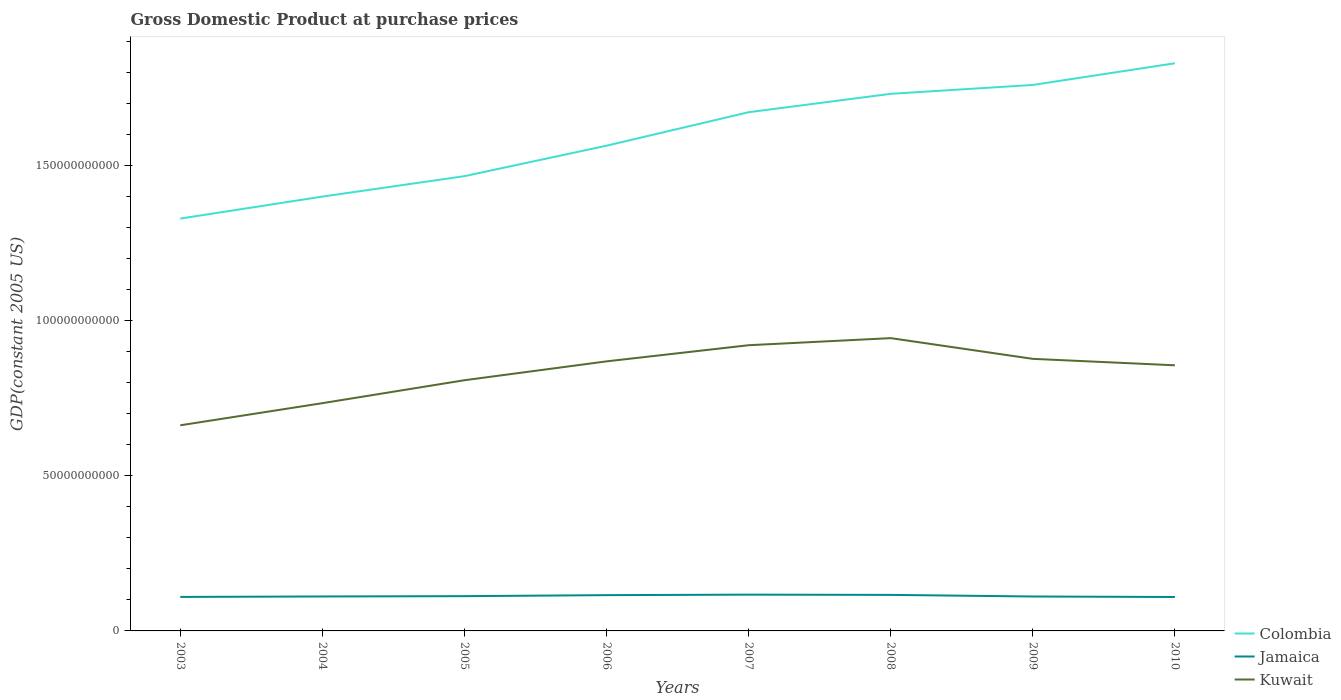How many different coloured lines are there?
Ensure brevity in your answer.  3. Across all years, what is the maximum GDP at purchase prices in Kuwait?
Offer a terse response. 6.63e+1. In which year was the GDP at purchase prices in Colombia maximum?
Make the answer very short. 2003. What is the total GDP at purchase prices in Kuwait in the graph?
Make the answer very short. -2.81e+1. What is the difference between the highest and the second highest GDP at purchase prices in Jamaica?
Make the answer very short. 7.63e+08. Is the GDP at purchase prices in Jamaica strictly greater than the GDP at purchase prices in Colombia over the years?
Give a very brief answer. Yes. How many years are there in the graph?
Give a very brief answer. 8. Does the graph contain grids?
Keep it short and to the point. No. How are the legend labels stacked?
Provide a succinct answer. Vertical. What is the title of the graph?
Your answer should be compact. Gross Domestic Product at purchase prices. What is the label or title of the X-axis?
Your answer should be compact. Years. What is the label or title of the Y-axis?
Give a very brief answer. GDP(constant 2005 US). What is the GDP(constant 2005 US) of Colombia in 2003?
Provide a short and direct response. 1.33e+11. What is the GDP(constant 2005 US) in Jamaica in 2003?
Offer a terse response. 1.10e+1. What is the GDP(constant 2005 US) of Kuwait in 2003?
Ensure brevity in your answer.  6.63e+1. What is the GDP(constant 2005 US) in Colombia in 2004?
Your response must be concise. 1.40e+11. What is the GDP(constant 2005 US) in Jamaica in 2004?
Offer a very short reply. 1.11e+1. What is the GDP(constant 2005 US) in Kuwait in 2004?
Offer a very short reply. 7.34e+1. What is the GDP(constant 2005 US) in Colombia in 2005?
Ensure brevity in your answer.  1.47e+11. What is the GDP(constant 2005 US) in Jamaica in 2005?
Keep it short and to the point. 1.12e+1. What is the GDP(constant 2005 US) of Kuwait in 2005?
Provide a short and direct response. 8.08e+1. What is the GDP(constant 2005 US) of Colombia in 2006?
Your answer should be compact. 1.56e+11. What is the GDP(constant 2005 US) in Jamaica in 2006?
Your response must be concise. 1.15e+1. What is the GDP(constant 2005 US) in Kuwait in 2006?
Ensure brevity in your answer.  8.69e+1. What is the GDP(constant 2005 US) in Colombia in 2007?
Give a very brief answer. 1.67e+11. What is the GDP(constant 2005 US) in Jamaica in 2007?
Offer a very short reply. 1.17e+1. What is the GDP(constant 2005 US) in Kuwait in 2007?
Provide a short and direct response. 9.21e+1. What is the GDP(constant 2005 US) of Colombia in 2008?
Make the answer very short. 1.73e+11. What is the GDP(constant 2005 US) of Jamaica in 2008?
Your response must be concise. 1.16e+1. What is the GDP(constant 2005 US) in Kuwait in 2008?
Your answer should be compact. 9.44e+1. What is the GDP(constant 2005 US) in Colombia in 2009?
Offer a terse response. 1.76e+11. What is the GDP(constant 2005 US) of Jamaica in 2009?
Give a very brief answer. 1.11e+1. What is the GDP(constant 2005 US) in Kuwait in 2009?
Provide a short and direct response. 8.77e+1. What is the GDP(constant 2005 US) in Colombia in 2010?
Offer a very short reply. 1.83e+11. What is the GDP(constant 2005 US) of Jamaica in 2010?
Make the answer very short. 1.09e+1. What is the GDP(constant 2005 US) of Kuwait in 2010?
Your answer should be compact. 8.56e+1. Across all years, what is the maximum GDP(constant 2005 US) of Colombia?
Give a very brief answer. 1.83e+11. Across all years, what is the maximum GDP(constant 2005 US) of Jamaica?
Ensure brevity in your answer.  1.17e+1. Across all years, what is the maximum GDP(constant 2005 US) of Kuwait?
Your answer should be compact. 9.44e+1. Across all years, what is the minimum GDP(constant 2005 US) of Colombia?
Your answer should be very brief. 1.33e+11. Across all years, what is the minimum GDP(constant 2005 US) in Jamaica?
Provide a short and direct response. 1.09e+1. Across all years, what is the minimum GDP(constant 2005 US) of Kuwait?
Make the answer very short. 6.63e+1. What is the total GDP(constant 2005 US) of Colombia in the graph?
Ensure brevity in your answer.  1.28e+12. What is the total GDP(constant 2005 US) of Jamaica in the graph?
Ensure brevity in your answer.  9.01e+1. What is the total GDP(constant 2005 US) of Kuwait in the graph?
Offer a terse response. 6.67e+11. What is the difference between the GDP(constant 2005 US) of Colombia in 2003 and that in 2004?
Provide a short and direct response. -7.09e+09. What is the difference between the GDP(constant 2005 US) of Jamaica in 2003 and that in 2004?
Provide a short and direct response. -1.45e+08. What is the difference between the GDP(constant 2005 US) of Kuwait in 2003 and that in 2004?
Ensure brevity in your answer.  -7.13e+09. What is the difference between the GDP(constant 2005 US) of Colombia in 2003 and that in 2005?
Your answer should be very brief. -1.37e+1. What is the difference between the GDP(constant 2005 US) of Jamaica in 2003 and that in 2005?
Your answer should be very brief. -2.44e+08. What is the difference between the GDP(constant 2005 US) in Kuwait in 2003 and that in 2005?
Ensure brevity in your answer.  -1.45e+1. What is the difference between the GDP(constant 2005 US) in Colombia in 2003 and that in 2006?
Make the answer very short. -2.35e+1. What is the difference between the GDP(constant 2005 US) of Jamaica in 2003 and that in 2006?
Ensure brevity in your answer.  -5.69e+08. What is the difference between the GDP(constant 2005 US) of Kuwait in 2003 and that in 2006?
Keep it short and to the point. -2.06e+1. What is the difference between the GDP(constant 2005 US) of Colombia in 2003 and that in 2007?
Offer a terse response. -3.43e+1. What is the difference between the GDP(constant 2005 US) in Jamaica in 2003 and that in 2007?
Your response must be concise. -7.34e+08. What is the difference between the GDP(constant 2005 US) in Kuwait in 2003 and that in 2007?
Offer a terse response. -2.58e+1. What is the difference between the GDP(constant 2005 US) in Colombia in 2003 and that in 2008?
Your response must be concise. -4.02e+1. What is the difference between the GDP(constant 2005 US) in Jamaica in 2003 and that in 2008?
Offer a terse response. -6.50e+08. What is the difference between the GDP(constant 2005 US) of Kuwait in 2003 and that in 2008?
Offer a terse response. -2.81e+1. What is the difference between the GDP(constant 2005 US) of Colombia in 2003 and that in 2009?
Your answer should be compact. -4.31e+1. What is the difference between the GDP(constant 2005 US) of Jamaica in 2003 and that in 2009?
Your response must be concise. -1.36e+08. What is the difference between the GDP(constant 2005 US) of Kuwait in 2003 and that in 2009?
Provide a succinct answer. -2.14e+1. What is the difference between the GDP(constant 2005 US) in Colombia in 2003 and that in 2010?
Offer a terse response. -5.01e+1. What is the difference between the GDP(constant 2005 US) in Jamaica in 2003 and that in 2010?
Offer a very short reply. 2.92e+07. What is the difference between the GDP(constant 2005 US) of Kuwait in 2003 and that in 2010?
Offer a terse response. -1.93e+1. What is the difference between the GDP(constant 2005 US) of Colombia in 2004 and that in 2005?
Your answer should be compact. -6.59e+09. What is the difference between the GDP(constant 2005 US) in Jamaica in 2004 and that in 2005?
Offer a terse response. -9.93e+07. What is the difference between the GDP(constant 2005 US) in Kuwait in 2004 and that in 2005?
Give a very brief answer. -7.40e+09. What is the difference between the GDP(constant 2005 US) in Colombia in 2004 and that in 2006?
Provide a short and direct response. -1.64e+1. What is the difference between the GDP(constant 2005 US) of Jamaica in 2004 and that in 2006?
Your answer should be compact. -4.24e+08. What is the difference between the GDP(constant 2005 US) in Kuwait in 2004 and that in 2006?
Your response must be concise. -1.35e+1. What is the difference between the GDP(constant 2005 US) in Colombia in 2004 and that in 2007?
Provide a short and direct response. -2.72e+1. What is the difference between the GDP(constant 2005 US) in Jamaica in 2004 and that in 2007?
Offer a very short reply. -5.89e+08. What is the difference between the GDP(constant 2005 US) of Kuwait in 2004 and that in 2007?
Your answer should be compact. -1.87e+1. What is the difference between the GDP(constant 2005 US) of Colombia in 2004 and that in 2008?
Keep it short and to the point. -3.31e+1. What is the difference between the GDP(constant 2005 US) in Jamaica in 2004 and that in 2008?
Provide a succinct answer. -5.05e+08. What is the difference between the GDP(constant 2005 US) of Kuwait in 2004 and that in 2008?
Ensure brevity in your answer.  -2.10e+1. What is the difference between the GDP(constant 2005 US) of Colombia in 2004 and that in 2009?
Your response must be concise. -3.60e+1. What is the difference between the GDP(constant 2005 US) of Jamaica in 2004 and that in 2009?
Give a very brief answer. 9.05e+06. What is the difference between the GDP(constant 2005 US) in Kuwait in 2004 and that in 2009?
Offer a terse response. -1.43e+1. What is the difference between the GDP(constant 2005 US) in Colombia in 2004 and that in 2010?
Your answer should be compact. -4.30e+1. What is the difference between the GDP(constant 2005 US) of Jamaica in 2004 and that in 2010?
Ensure brevity in your answer.  1.74e+08. What is the difference between the GDP(constant 2005 US) of Kuwait in 2004 and that in 2010?
Keep it short and to the point. -1.22e+1. What is the difference between the GDP(constant 2005 US) of Colombia in 2005 and that in 2006?
Your answer should be compact. -9.82e+09. What is the difference between the GDP(constant 2005 US) of Jamaica in 2005 and that in 2006?
Provide a succinct answer. -3.25e+08. What is the difference between the GDP(constant 2005 US) in Kuwait in 2005 and that in 2006?
Give a very brief answer. -6.08e+09. What is the difference between the GDP(constant 2005 US) in Colombia in 2005 and that in 2007?
Provide a short and direct response. -2.06e+1. What is the difference between the GDP(constant 2005 US) of Jamaica in 2005 and that in 2007?
Offer a very short reply. -4.90e+08. What is the difference between the GDP(constant 2005 US) in Kuwait in 2005 and that in 2007?
Provide a short and direct response. -1.13e+1. What is the difference between the GDP(constant 2005 US) of Colombia in 2005 and that in 2008?
Your response must be concise. -2.65e+1. What is the difference between the GDP(constant 2005 US) in Jamaica in 2005 and that in 2008?
Provide a succinct answer. -4.05e+08. What is the difference between the GDP(constant 2005 US) of Kuwait in 2005 and that in 2008?
Provide a short and direct response. -1.36e+1. What is the difference between the GDP(constant 2005 US) of Colombia in 2005 and that in 2009?
Give a very brief answer. -2.94e+1. What is the difference between the GDP(constant 2005 US) in Jamaica in 2005 and that in 2009?
Offer a very short reply. 1.08e+08. What is the difference between the GDP(constant 2005 US) in Kuwait in 2005 and that in 2009?
Your answer should be compact. -6.89e+09. What is the difference between the GDP(constant 2005 US) in Colombia in 2005 and that in 2010?
Your answer should be very brief. -3.64e+1. What is the difference between the GDP(constant 2005 US) in Jamaica in 2005 and that in 2010?
Your answer should be compact. 2.74e+08. What is the difference between the GDP(constant 2005 US) in Kuwait in 2005 and that in 2010?
Provide a short and direct response. -4.81e+09. What is the difference between the GDP(constant 2005 US) in Colombia in 2006 and that in 2007?
Your answer should be compact. -1.08e+1. What is the difference between the GDP(constant 2005 US) of Jamaica in 2006 and that in 2007?
Your response must be concise. -1.65e+08. What is the difference between the GDP(constant 2005 US) in Kuwait in 2006 and that in 2007?
Keep it short and to the point. -5.21e+09. What is the difference between the GDP(constant 2005 US) of Colombia in 2006 and that in 2008?
Your response must be concise. -1.67e+1. What is the difference between the GDP(constant 2005 US) in Jamaica in 2006 and that in 2008?
Your answer should be very brief. -8.06e+07. What is the difference between the GDP(constant 2005 US) in Kuwait in 2006 and that in 2008?
Make the answer very short. -7.49e+09. What is the difference between the GDP(constant 2005 US) in Colombia in 2006 and that in 2009?
Offer a terse response. -1.96e+1. What is the difference between the GDP(constant 2005 US) of Jamaica in 2006 and that in 2009?
Offer a terse response. 4.33e+08. What is the difference between the GDP(constant 2005 US) of Kuwait in 2006 and that in 2009?
Provide a short and direct response. -8.11e+08. What is the difference between the GDP(constant 2005 US) in Colombia in 2006 and that in 2010?
Your response must be concise. -2.66e+1. What is the difference between the GDP(constant 2005 US) in Jamaica in 2006 and that in 2010?
Your answer should be compact. 5.98e+08. What is the difference between the GDP(constant 2005 US) in Kuwait in 2006 and that in 2010?
Offer a terse response. 1.26e+09. What is the difference between the GDP(constant 2005 US) of Colombia in 2007 and that in 2008?
Your response must be concise. -5.93e+09. What is the difference between the GDP(constant 2005 US) of Jamaica in 2007 and that in 2008?
Your answer should be compact. 8.45e+07. What is the difference between the GDP(constant 2005 US) of Kuwait in 2007 and that in 2008?
Ensure brevity in your answer.  -2.28e+09. What is the difference between the GDP(constant 2005 US) in Colombia in 2007 and that in 2009?
Provide a short and direct response. -8.79e+09. What is the difference between the GDP(constant 2005 US) in Jamaica in 2007 and that in 2009?
Offer a very short reply. 5.98e+08. What is the difference between the GDP(constant 2005 US) in Kuwait in 2007 and that in 2009?
Your answer should be compact. 4.39e+09. What is the difference between the GDP(constant 2005 US) of Colombia in 2007 and that in 2010?
Offer a terse response. -1.58e+1. What is the difference between the GDP(constant 2005 US) in Jamaica in 2007 and that in 2010?
Offer a terse response. 7.63e+08. What is the difference between the GDP(constant 2005 US) in Kuwait in 2007 and that in 2010?
Your answer should be very brief. 6.47e+09. What is the difference between the GDP(constant 2005 US) in Colombia in 2008 and that in 2009?
Provide a short and direct response. -2.86e+09. What is the difference between the GDP(constant 2005 US) of Jamaica in 2008 and that in 2009?
Make the answer very short. 5.14e+08. What is the difference between the GDP(constant 2005 US) in Kuwait in 2008 and that in 2009?
Give a very brief answer. 6.68e+09. What is the difference between the GDP(constant 2005 US) in Colombia in 2008 and that in 2010?
Offer a very short reply. -9.85e+09. What is the difference between the GDP(constant 2005 US) of Jamaica in 2008 and that in 2010?
Offer a terse response. 6.79e+08. What is the difference between the GDP(constant 2005 US) in Kuwait in 2008 and that in 2010?
Your response must be concise. 8.75e+09. What is the difference between the GDP(constant 2005 US) in Colombia in 2009 and that in 2010?
Your answer should be compact. -6.99e+09. What is the difference between the GDP(constant 2005 US) of Jamaica in 2009 and that in 2010?
Provide a succinct answer. 1.65e+08. What is the difference between the GDP(constant 2005 US) in Kuwait in 2009 and that in 2010?
Keep it short and to the point. 2.08e+09. What is the difference between the GDP(constant 2005 US) of Colombia in 2003 and the GDP(constant 2005 US) of Jamaica in 2004?
Give a very brief answer. 1.22e+11. What is the difference between the GDP(constant 2005 US) in Colombia in 2003 and the GDP(constant 2005 US) in Kuwait in 2004?
Ensure brevity in your answer.  5.95e+1. What is the difference between the GDP(constant 2005 US) in Jamaica in 2003 and the GDP(constant 2005 US) in Kuwait in 2004?
Provide a succinct answer. -6.24e+1. What is the difference between the GDP(constant 2005 US) in Colombia in 2003 and the GDP(constant 2005 US) in Jamaica in 2005?
Offer a very short reply. 1.22e+11. What is the difference between the GDP(constant 2005 US) of Colombia in 2003 and the GDP(constant 2005 US) of Kuwait in 2005?
Your answer should be very brief. 5.21e+1. What is the difference between the GDP(constant 2005 US) in Jamaica in 2003 and the GDP(constant 2005 US) in Kuwait in 2005?
Provide a succinct answer. -6.98e+1. What is the difference between the GDP(constant 2005 US) of Colombia in 2003 and the GDP(constant 2005 US) of Jamaica in 2006?
Your response must be concise. 1.21e+11. What is the difference between the GDP(constant 2005 US) of Colombia in 2003 and the GDP(constant 2005 US) of Kuwait in 2006?
Make the answer very short. 4.60e+1. What is the difference between the GDP(constant 2005 US) in Jamaica in 2003 and the GDP(constant 2005 US) in Kuwait in 2006?
Offer a terse response. -7.59e+1. What is the difference between the GDP(constant 2005 US) in Colombia in 2003 and the GDP(constant 2005 US) in Jamaica in 2007?
Your answer should be very brief. 1.21e+11. What is the difference between the GDP(constant 2005 US) of Colombia in 2003 and the GDP(constant 2005 US) of Kuwait in 2007?
Offer a very short reply. 4.08e+1. What is the difference between the GDP(constant 2005 US) of Jamaica in 2003 and the GDP(constant 2005 US) of Kuwait in 2007?
Your answer should be very brief. -8.11e+1. What is the difference between the GDP(constant 2005 US) in Colombia in 2003 and the GDP(constant 2005 US) in Jamaica in 2008?
Offer a terse response. 1.21e+11. What is the difference between the GDP(constant 2005 US) of Colombia in 2003 and the GDP(constant 2005 US) of Kuwait in 2008?
Keep it short and to the point. 3.85e+1. What is the difference between the GDP(constant 2005 US) in Jamaica in 2003 and the GDP(constant 2005 US) in Kuwait in 2008?
Make the answer very short. -8.34e+1. What is the difference between the GDP(constant 2005 US) of Colombia in 2003 and the GDP(constant 2005 US) of Jamaica in 2009?
Offer a terse response. 1.22e+11. What is the difference between the GDP(constant 2005 US) in Colombia in 2003 and the GDP(constant 2005 US) in Kuwait in 2009?
Make the answer very short. 4.52e+1. What is the difference between the GDP(constant 2005 US) in Jamaica in 2003 and the GDP(constant 2005 US) in Kuwait in 2009?
Provide a short and direct response. -7.67e+1. What is the difference between the GDP(constant 2005 US) of Colombia in 2003 and the GDP(constant 2005 US) of Jamaica in 2010?
Provide a short and direct response. 1.22e+11. What is the difference between the GDP(constant 2005 US) in Colombia in 2003 and the GDP(constant 2005 US) in Kuwait in 2010?
Give a very brief answer. 4.73e+1. What is the difference between the GDP(constant 2005 US) in Jamaica in 2003 and the GDP(constant 2005 US) in Kuwait in 2010?
Make the answer very short. -7.46e+1. What is the difference between the GDP(constant 2005 US) of Colombia in 2004 and the GDP(constant 2005 US) of Jamaica in 2005?
Your answer should be compact. 1.29e+11. What is the difference between the GDP(constant 2005 US) in Colombia in 2004 and the GDP(constant 2005 US) in Kuwait in 2005?
Provide a succinct answer. 5.92e+1. What is the difference between the GDP(constant 2005 US) of Jamaica in 2004 and the GDP(constant 2005 US) of Kuwait in 2005?
Provide a succinct answer. -6.97e+1. What is the difference between the GDP(constant 2005 US) of Colombia in 2004 and the GDP(constant 2005 US) of Jamaica in 2006?
Offer a very short reply. 1.28e+11. What is the difference between the GDP(constant 2005 US) in Colombia in 2004 and the GDP(constant 2005 US) in Kuwait in 2006?
Your answer should be compact. 5.31e+1. What is the difference between the GDP(constant 2005 US) of Jamaica in 2004 and the GDP(constant 2005 US) of Kuwait in 2006?
Offer a terse response. -7.58e+1. What is the difference between the GDP(constant 2005 US) of Colombia in 2004 and the GDP(constant 2005 US) of Jamaica in 2007?
Your answer should be compact. 1.28e+11. What is the difference between the GDP(constant 2005 US) of Colombia in 2004 and the GDP(constant 2005 US) of Kuwait in 2007?
Your answer should be very brief. 4.79e+1. What is the difference between the GDP(constant 2005 US) of Jamaica in 2004 and the GDP(constant 2005 US) of Kuwait in 2007?
Make the answer very short. -8.10e+1. What is the difference between the GDP(constant 2005 US) of Colombia in 2004 and the GDP(constant 2005 US) of Jamaica in 2008?
Your response must be concise. 1.28e+11. What is the difference between the GDP(constant 2005 US) of Colombia in 2004 and the GDP(constant 2005 US) of Kuwait in 2008?
Offer a very short reply. 4.56e+1. What is the difference between the GDP(constant 2005 US) of Jamaica in 2004 and the GDP(constant 2005 US) of Kuwait in 2008?
Provide a succinct answer. -8.33e+1. What is the difference between the GDP(constant 2005 US) in Colombia in 2004 and the GDP(constant 2005 US) in Jamaica in 2009?
Your response must be concise. 1.29e+11. What is the difference between the GDP(constant 2005 US) in Colombia in 2004 and the GDP(constant 2005 US) in Kuwait in 2009?
Give a very brief answer. 5.23e+1. What is the difference between the GDP(constant 2005 US) of Jamaica in 2004 and the GDP(constant 2005 US) of Kuwait in 2009?
Your response must be concise. -7.66e+1. What is the difference between the GDP(constant 2005 US) in Colombia in 2004 and the GDP(constant 2005 US) in Jamaica in 2010?
Offer a very short reply. 1.29e+11. What is the difference between the GDP(constant 2005 US) in Colombia in 2004 and the GDP(constant 2005 US) in Kuwait in 2010?
Offer a very short reply. 5.44e+1. What is the difference between the GDP(constant 2005 US) of Jamaica in 2004 and the GDP(constant 2005 US) of Kuwait in 2010?
Ensure brevity in your answer.  -7.45e+1. What is the difference between the GDP(constant 2005 US) of Colombia in 2005 and the GDP(constant 2005 US) of Jamaica in 2006?
Your answer should be very brief. 1.35e+11. What is the difference between the GDP(constant 2005 US) in Colombia in 2005 and the GDP(constant 2005 US) in Kuwait in 2006?
Your response must be concise. 5.97e+1. What is the difference between the GDP(constant 2005 US) in Jamaica in 2005 and the GDP(constant 2005 US) in Kuwait in 2006?
Your response must be concise. -7.57e+1. What is the difference between the GDP(constant 2005 US) in Colombia in 2005 and the GDP(constant 2005 US) in Jamaica in 2007?
Offer a terse response. 1.35e+11. What is the difference between the GDP(constant 2005 US) in Colombia in 2005 and the GDP(constant 2005 US) in Kuwait in 2007?
Offer a very short reply. 5.45e+1. What is the difference between the GDP(constant 2005 US) of Jamaica in 2005 and the GDP(constant 2005 US) of Kuwait in 2007?
Keep it short and to the point. -8.09e+1. What is the difference between the GDP(constant 2005 US) of Colombia in 2005 and the GDP(constant 2005 US) of Jamaica in 2008?
Give a very brief answer. 1.35e+11. What is the difference between the GDP(constant 2005 US) of Colombia in 2005 and the GDP(constant 2005 US) of Kuwait in 2008?
Provide a succinct answer. 5.22e+1. What is the difference between the GDP(constant 2005 US) of Jamaica in 2005 and the GDP(constant 2005 US) of Kuwait in 2008?
Make the answer very short. -8.32e+1. What is the difference between the GDP(constant 2005 US) of Colombia in 2005 and the GDP(constant 2005 US) of Jamaica in 2009?
Keep it short and to the point. 1.35e+11. What is the difference between the GDP(constant 2005 US) of Colombia in 2005 and the GDP(constant 2005 US) of Kuwait in 2009?
Provide a succinct answer. 5.89e+1. What is the difference between the GDP(constant 2005 US) of Jamaica in 2005 and the GDP(constant 2005 US) of Kuwait in 2009?
Make the answer very short. -7.65e+1. What is the difference between the GDP(constant 2005 US) in Colombia in 2005 and the GDP(constant 2005 US) in Jamaica in 2010?
Provide a short and direct response. 1.36e+11. What is the difference between the GDP(constant 2005 US) in Colombia in 2005 and the GDP(constant 2005 US) in Kuwait in 2010?
Give a very brief answer. 6.10e+1. What is the difference between the GDP(constant 2005 US) of Jamaica in 2005 and the GDP(constant 2005 US) of Kuwait in 2010?
Keep it short and to the point. -7.44e+1. What is the difference between the GDP(constant 2005 US) in Colombia in 2006 and the GDP(constant 2005 US) in Jamaica in 2007?
Give a very brief answer. 1.45e+11. What is the difference between the GDP(constant 2005 US) in Colombia in 2006 and the GDP(constant 2005 US) in Kuwait in 2007?
Keep it short and to the point. 6.43e+1. What is the difference between the GDP(constant 2005 US) in Jamaica in 2006 and the GDP(constant 2005 US) in Kuwait in 2007?
Provide a succinct answer. -8.06e+1. What is the difference between the GDP(constant 2005 US) in Colombia in 2006 and the GDP(constant 2005 US) in Jamaica in 2008?
Give a very brief answer. 1.45e+11. What is the difference between the GDP(constant 2005 US) of Colombia in 2006 and the GDP(constant 2005 US) of Kuwait in 2008?
Your answer should be very brief. 6.20e+1. What is the difference between the GDP(constant 2005 US) of Jamaica in 2006 and the GDP(constant 2005 US) of Kuwait in 2008?
Make the answer very short. -8.28e+1. What is the difference between the GDP(constant 2005 US) of Colombia in 2006 and the GDP(constant 2005 US) of Jamaica in 2009?
Ensure brevity in your answer.  1.45e+11. What is the difference between the GDP(constant 2005 US) of Colombia in 2006 and the GDP(constant 2005 US) of Kuwait in 2009?
Keep it short and to the point. 6.87e+1. What is the difference between the GDP(constant 2005 US) in Jamaica in 2006 and the GDP(constant 2005 US) in Kuwait in 2009?
Give a very brief answer. -7.62e+1. What is the difference between the GDP(constant 2005 US) of Colombia in 2006 and the GDP(constant 2005 US) of Jamaica in 2010?
Ensure brevity in your answer.  1.45e+11. What is the difference between the GDP(constant 2005 US) of Colombia in 2006 and the GDP(constant 2005 US) of Kuwait in 2010?
Your response must be concise. 7.08e+1. What is the difference between the GDP(constant 2005 US) in Jamaica in 2006 and the GDP(constant 2005 US) in Kuwait in 2010?
Provide a short and direct response. -7.41e+1. What is the difference between the GDP(constant 2005 US) in Colombia in 2007 and the GDP(constant 2005 US) in Jamaica in 2008?
Your answer should be very brief. 1.56e+11. What is the difference between the GDP(constant 2005 US) of Colombia in 2007 and the GDP(constant 2005 US) of Kuwait in 2008?
Provide a short and direct response. 7.28e+1. What is the difference between the GDP(constant 2005 US) in Jamaica in 2007 and the GDP(constant 2005 US) in Kuwait in 2008?
Your answer should be very brief. -8.27e+1. What is the difference between the GDP(constant 2005 US) in Colombia in 2007 and the GDP(constant 2005 US) in Jamaica in 2009?
Your answer should be compact. 1.56e+11. What is the difference between the GDP(constant 2005 US) of Colombia in 2007 and the GDP(constant 2005 US) of Kuwait in 2009?
Keep it short and to the point. 7.95e+1. What is the difference between the GDP(constant 2005 US) in Jamaica in 2007 and the GDP(constant 2005 US) in Kuwait in 2009?
Provide a succinct answer. -7.60e+1. What is the difference between the GDP(constant 2005 US) in Colombia in 2007 and the GDP(constant 2005 US) in Jamaica in 2010?
Ensure brevity in your answer.  1.56e+11. What is the difference between the GDP(constant 2005 US) of Colombia in 2007 and the GDP(constant 2005 US) of Kuwait in 2010?
Your answer should be compact. 8.16e+1. What is the difference between the GDP(constant 2005 US) in Jamaica in 2007 and the GDP(constant 2005 US) in Kuwait in 2010?
Give a very brief answer. -7.39e+1. What is the difference between the GDP(constant 2005 US) in Colombia in 2008 and the GDP(constant 2005 US) in Jamaica in 2009?
Give a very brief answer. 1.62e+11. What is the difference between the GDP(constant 2005 US) of Colombia in 2008 and the GDP(constant 2005 US) of Kuwait in 2009?
Keep it short and to the point. 8.54e+1. What is the difference between the GDP(constant 2005 US) in Jamaica in 2008 and the GDP(constant 2005 US) in Kuwait in 2009?
Your response must be concise. -7.61e+1. What is the difference between the GDP(constant 2005 US) in Colombia in 2008 and the GDP(constant 2005 US) in Jamaica in 2010?
Provide a short and direct response. 1.62e+11. What is the difference between the GDP(constant 2005 US) of Colombia in 2008 and the GDP(constant 2005 US) of Kuwait in 2010?
Offer a terse response. 8.75e+1. What is the difference between the GDP(constant 2005 US) in Jamaica in 2008 and the GDP(constant 2005 US) in Kuwait in 2010?
Your answer should be very brief. -7.40e+1. What is the difference between the GDP(constant 2005 US) of Colombia in 2009 and the GDP(constant 2005 US) of Jamaica in 2010?
Your answer should be very brief. 1.65e+11. What is the difference between the GDP(constant 2005 US) of Colombia in 2009 and the GDP(constant 2005 US) of Kuwait in 2010?
Offer a very short reply. 9.04e+1. What is the difference between the GDP(constant 2005 US) of Jamaica in 2009 and the GDP(constant 2005 US) of Kuwait in 2010?
Provide a short and direct response. -7.45e+1. What is the average GDP(constant 2005 US) in Colombia per year?
Provide a short and direct response. 1.59e+11. What is the average GDP(constant 2005 US) in Jamaica per year?
Make the answer very short. 1.13e+1. What is the average GDP(constant 2005 US) in Kuwait per year?
Your answer should be very brief. 8.34e+1. In the year 2003, what is the difference between the GDP(constant 2005 US) in Colombia and GDP(constant 2005 US) in Jamaica?
Ensure brevity in your answer.  1.22e+11. In the year 2003, what is the difference between the GDP(constant 2005 US) of Colombia and GDP(constant 2005 US) of Kuwait?
Your response must be concise. 6.66e+1. In the year 2003, what is the difference between the GDP(constant 2005 US) in Jamaica and GDP(constant 2005 US) in Kuwait?
Make the answer very short. -5.53e+1. In the year 2004, what is the difference between the GDP(constant 2005 US) of Colombia and GDP(constant 2005 US) of Jamaica?
Your answer should be compact. 1.29e+11. In the year 2004, what is the difference between the GDP(constant 2005 US) of Colombia and GDP(constant 2005 US) of Kuwait?
Offer a terse response. 6.66e+1. In the year 2004, what is the difference between the GDP(constant 2005 US) of Jamaica and GDP(constant 2005 US) of Kuwait?
Your answer should be compact. -6.23e+1. In the year 2005, what is the difference between the GDP(constant 2005 US) in Colombia and GDP(constant 2005 US) in Jamaica?
Provide a short and direct response. 1.35e+11. In the year 2005, what is the difference between the GDP(constant 2005 US) in Colombia and GDP(constant 2005 US) in Kuwait?
Offer a very short reply. 6.58e+1. In the year 2005, what is the difference between the GDP(constant 2005 US) of Jamaica and GDP(constant 2005 US) of Kuwait?
Offer a very short reply. -6.96e+1. In the year 2006, what is the difference between the GDP(constant 2005 US) in Colombia and GDP(constant 2005 US) in Jamaica?
Your response must be concise. 1.45e+11. In the year 2006, what is the difference between the GDP(constant 2005 US) of Colombia and GDP(constant 2005 US) of Kuwait?
Ensure brevity in your answer.  6.95e+1. In the year 2006, what is the difference between the GDP(constant 2005 US) in Jamaica and GDP(constant 2005 US) in Kuwait?
Provide a succinct answer. -7.53e+1. In the year 2007, what is the difference between the GDP(constant 2005 US) of Colombia and GDP(constant 2005 US) of Jamaica?
Your answer should be very brief. 1.55e+11. In the year 2007, what is the difference between the GDP(constant 2005 US) of Colombia and GDP(constant 2005 US) of Kuwait?
Provide a succinct answer. 7.51e+1. In the year 2007, what is the difference between the GDP(constant 2005 US) in Jamaica and GDP(constant 2005 US) in Kuwait?
Offer a very short reply. -8.04e+1. In the year 2008, what is the difference between the GDP(constant 2005 US) of Colombia and GDP(constant 2005 US) of Jamaica?
Your response must be concise. 1.61e+11. In the year 2008, what is the difference between the GDP(constant 2005 US) of Colombia and GDP(constant 2005 US) of Kuwait?
Provide a short and direct response. 7.87e+1. In the year 2008, what is the difference between the GDP(constant 2005 US) in Jamaica and GDP(constant 2005 US) in Kuwait?
Offer a very short reply. -8.28e+1. In the year 2009, what is the difference between the GDP(constant 2005 US) of Colombia and GDP(constant 2005 US) of Jamaica?
Keep it short and to the point. 1.65e+11. In the year 2009, what is the difference between the GDP(constant 2005 US) of Colombia and GDP(constant 2005 US) of Kuwait?
Make the answer very short. 8.83e+1. In the year 2009, what is the difference between the GDP(constant 2005 US) in Jamaica and GDP(constant 2005 US) in Kuwait?
Your answer should be very brief. -7.66e+1. In the year 2010, what is the difference between the GDP(constant 2005 US) in Colombia and GDP(constant 2005 US) in Jamaica?
Offer a very short reply. 1.72e+11. In the year 2010, what is the difference between the GDP(constant 2005 US) of Colombia and GDP(constant 2005 US) of Kuwait?
Make the answer very short. 9.73e+1. In the year 2010, what is the difference between the GDP(constant 2005 US) in Jamaica and GDP(constant 2005 US) in Kuwait?
Provide a short and direct response. -7.47e+1. What is the ratio of the GDP(constant 2005 US) in Colombia in 2003 to that in 2004?
Keep it short and to the point. 0.95. What is the ratio of the GDP(constant 2005 US) of Jamaica in 2003 to that in 2004?
Keep it short and to the point. 0.99. What is the ratio of the GDP(constant 2005 US) of Kuwait in 2003 to that in 2004?
Ensure brevity in your answer.  0.9. What is the ratio of the GDP(constant 2005 US) in Colombia in 2003 to that in 2005?
Keep it short and to the point. 0.91. What is the ratio of the GDP(constant 2005 US) of Jamaica in 2003 to that in 2005?
Keep it short and to the point. 0.98. What is the ratio of the GDP(constant 2005 US) in Kuwait in 2003 to that in 2005?
Make the answer very short. 0.82. What is the ratio of the GDP(constant 2005 US) in Colombia in 2003 to that in 2006?
Your response must be concise. 0.85. What is the ratio of the GDP(constant 2005 US) of Jamaica in 2003 to that in 2006?
Give a very brief answer. 0.95. What is the ratio of the GDP(constant 2005 US) of Kuwait in 2003 to that in 2006?
Keep it short and to the point. 0.76. What is the ratio of the GDP(constant 2005 US) in Colombia in 2003 to that in 2007?
Offer a terse response. 0.79. What is the ratio of the GDP(constant 2005 US) in Jamaica in 2003 to that in 2007?
Give a very brief answer. 0.94. What is the ratio of the GDP(constant 2005 US) of Kuwait in 2003 to that in 2007?
Your response must be concise. 0.72. What is the ratio of the GDP(constant 2005 US) of Colombia in 2003 to that in 2008?
Provide a succinct answer. 0.77. What is the ratio of the GDP(constant 2005 US) of Jamaica in 2003 to that in 2008?
Give a very brief answer. 0.94. What is the ratio of the GDP(constant 2005 US) of Kuwait in 2003 to that in 2008?
Provide a short and direct response. 0.7. What is the ratio of the GDP(constant 2005 US) in Colombia in 2003 to that in 2009?
Offer a very short reply. 0.76. What is the ratio of the GDP(constant 2005 US) of Jamaica in 2003 to that in 2009?
Offer a terse response. 0.99. What is the ratio of the GDP(constant 2005 US) of Kuwait in 2003 to that in 2009?
Make the answer very short. 0.76. What is the ratio of the GDP(constant 2005 US) in Colombia in 2003 to that in 2010?
Your answer should be compact. 0.73. What is the ratio of the GDP(constant 2005 US) in Kuwait in 2003 to that in 2010?
Provide a succinct answer. 0.77. What is the ratio of the GDP(constant 2005 US) in Colombia in 2004 to that in 2005?
Your answer should be compact. 0.96. What is the ratio of the GDP(constant 2005 US) of Jamaica in 2004 to that in 2005?
Provide a succinct answer. 0.99. What is the ratio of the GDP(constant 2005 US) in Kuwait in 2004 to that in 2005?
Your answer should be very brief. 0.91. What is the ratio of the GDP(constant 2005 US) of Colombia in 2004 to that in 2006?
Your response must be concise. 0.9. What is the ratio of the GDP(constant 2005 US) of Jamaica in 2004 to that in 2006?
Offer a very short reply. 0.96. What is the ratio of the GDP(constant 2005 US) of Kuwait in 2004 to that in 2006?
Provide a short and direct response. 0.84. What is the ratio of the GDP(constant 2005 US) in Colombia in 2004 to that in 2007?
Provide a short and direct response. 0.84. What is the ratio of the GDP(constant 2005 US) in Jamaica in 2004 to that in 2007?
Offer a terse response. 0.95. What is the ratio of the GDP(constant 2005 US) of Kuwait in 2004 to that in 2007?
Provide a short and direct response. 0.8. What is the ratio of the GDP(constant 2005 US) in Colombia in 2004 to that in 2008?
Offer a terse response. 0.81. What is the ratio of the GDP(constant 2005 US) in Jamaica in 2004 to that in 2008?
Ensure brevity in your answer.  0.96. What is the ratio of the GDP(constant 2005 US) of Kuwait in 2004 to that in 2008?
Make the answer very short. 0.78. What is the ratio of the GDP(constant 2005 US) of Colombia in 2004 to that in 2009?
Offer a very short reply. 0.8. What is the ratio of the GDP(constant 2005 US) in Jamaica in 2004 to that in 2009?
Keep it short and to the point. 1. What is the ratio of the GDP(constant 2005 US) in Kuwait in 2004 to that in 2009?
Provide a short and direct response. 0.84. What is the ratio of the GDP(constant 2005 US) in Colombia in 2004 to that in 2010?
Your response must be concise. 0.77. What is the ratio of the GDP(constant 2005 US) of Jamaica in 2004 to that in 2010?
Keep it short and to the point. 1.02. What is the ratio of the GDP(constant 2005 US) of Kuwait in 2004 to that in 2010?
Provide a succinct answer. 0.86. What is the ratio of the GDP(constant 2005 US) of Colombia in 2005 to that in 2006?
Give a very brief answer. 0.94. What is the ratio of the GDP(constant 2005 US) in Jamaica in 2005 to that in 2006?
Make the answer very short. 0.97. What is the ratio of the GDP(constant 2005 US) in Kuwait in 2005 to that in 2006?
Offer a very short reply. 0.93. What is the ratio of the GDP(constant 2005 US) of Colombia in 2005 to that in 2007?
Your answer should be very brief. 0.88. What is the ratio of the GDP(constant 2005 US) of Jamaica in 2005 to that in 2007?
Offer a very short reply. 0.96. What is the ratio of the GDP(constant 2005 US) of Kuwait in 2005 to that in 2007?
Keep it short and to the point. 0.88. What is the ratio of the GDP(constant 2005 US) in Colombia in 2005 to that in 2008?
Your answer should be very brief. 0.85. What is the ratio of the GDP(constant 2005 US) of Jamaica in 2005 to that in 2008?
Ensure brevity in your answer.  0.97. What is the ratio of the GDP(constant 2005 US) in Kuwait in 2005 to that in 2008?
Your answer should be very brief. 0.86. What is the ratio of the GDP(constant 2005 US) of Colombia in 2005 to that in 2009?
Your response must be concise. 0.83. What is the ratio of the GDP(constant 2005 US) in Jamaica in 2005 to that in 2009?
Your answer should be very brief. 1.01. What is the ratio of the GDP(constant 2005 US) of Kuwait in 2005 to that in 2009?
Make the answer very short. 0.92. What is the ratio of the GDP(constant 2005 US) of Colombia in 2005 to that in 2010?
Your answer should be compact. 0.8. What is the ratio of the GDP(constant 2005 US) in Kuwait in 2005 to that in 2010?
Ensure brevity in your answer.  0.94. What is the ratio of the GDP(constant 2005 US) of Colombia in 2006 to that in 2007?
Make the answer very short. 0.94. What is the ratio of the GDP(constant 2005 US) of Jamaica in 2006 to that in 2007?
Your answer should be compact. 0.99. What is the ratio of the GDP(constant 2005 US) of Kuwait in 2006 to that in 2007?
Give a very brief answer. 0.94. What is the ratio of the GDP(constant 2005 US) of Colombia in 2006 to that in 2008?
Provide a short and direct response. 0.9. What is the ratio of the GDP(constant 2005 US) of Kuwait in 2006 to that in 2008?
Your answer should be very brief. 0.92. What is the ratio of the GDP(constant 2005 US) of Colombia in 2006 to that in 2009?
Provide a succinct answer. 0.89. What is the ratio of the GDP(constant 2005 US) in Jamaica in 2006 to that in 2009?
Your response must be concise. 1.04. What is the ratio of the GDP(constant 2005 US) of Colombia in 2006 to that in 2010?
Provide a succinct answer. 0.85. What is the ratio of the GDP(constant 2005 US) of Jamaica in 2006 to that in 2010?
Your answer should be compact. 1.05. What is the ratio of the GDP(constant 2005 US) in Kuwait in 2006 to that in 2010?
Keep it short and to the point. 1.01. What is the ratio of the GDP(constant 2005 US) in Colombia in 2007 to that in 2008?
Your response must be concise. 0.97. What is the ratio of the GDP(constant 2005 US) in Jamaica in 2007 to that in 2008?
Ensure brevity in your answer.  1.01. What is the ratio of the GDP(constant 2005 US) in Kuwait in 2007 to that in 2008?
Your response must be concise. 0.98. What is the ratio of the GDP(constant 2005 US) of Colombia in 2007 to that in 2009?
Give a very brief answer. 0.95. What is the ratio of the GDP(constant 2005 US) in Jamaica in 2007 to that in 2009?
Ensure brevity in your answer.  1.05. What is the ratio of the GDP(constant 2005 US) of Kuwait in 2007 to that in 2009?
Offer a very short reply. 1.05. What is the ratio of the GDP(constant 2005 US) of Colombia in 2007 to that in 2010?
Your answer should be very brief. 0.91. What is the ratio of the GDP(constant 2005 US) of Jamaica in 2007 to that in 2010?
Provide a short and direct response. 1.07. What is the ratio of the GDP(constant 2005 US) of Kuwait in 2007 to that in 2010?
Keep it short and to the point. 1.08. What is the ratio of the GDP(constant 2005 US) in Colombia in 2008 to that in 2009?
Your response must be concise. 0.98. What is the ratio of the GDP(constant 2005 US) of Jamaica in 2008 to that in 2009?
Provide a short and direct response. 1.05. What is the ratio of the GDP(constant 2005 US) in Kuwait in 2008 to that in 2009?
Offer a very short reply. 1.08. What is the ratio of the GDP(constant 2005 US) of Colombia in 2008 to that in 2010?
Your response must be concise. 0.95. What is the ratio of the GDP(constant 2005 US) of Jamaica in 2008 to that in 2010?
Make the answer very short. 1.06. What is the ratio of the GDP(constant 2005 US) in Kuwait in 2008 to that in 2010?
Your answer should be very brief. 1.1. What is the ratio of the GDP(constant 2005 US) of Colombia in 2009 to that in 2010?
Give a very brief answer. 0.96. What is the ratio of the GDP(constant 2005 US) in Jamaica in 2009 to that in 2010?
Your answer should be very brief. 1.02. What is the ratio of the GDP(constant 2005 US) of Kuwait in 2009 to that in 2010?
Keep it short and to the point. 1.02. What is the difference between the highest and the second highest GDP(constant 2005 US) of Colombia?
Offer a terse response. 6.99e+09. What is the difference between the highest and the second highest GDP(constant 2005 US) of Jamaica?
Your response must be concise. 8.45e+07. What is the difference between the highest and the second highest GDP(constant 2005 US) in Kuwait?
Provide a succinct answer. 2.28e+09. What is the difference between the highest and the lowest GDP(constant 2005 US) in Colombia?
Your response must be concise. 5.01e+1. What is the difference between the highest and the lowest GDP(constant 2005 US) in Jamaica?
Offer a very short reply. 7.63e+08. What is the difference between the highest and the lowest GDP(constant 2005 US) of Kuwait?
Offer a terse response. 2.81e+1. 